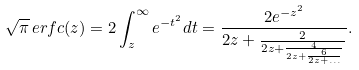Convert formula to latex. <formula><loc_0><loc_0><loc_500><loc_500>\sqrt { \pi } \, e r f c ( z ) = 2 \int ^ { \infty } _ { z } e ^ { - t ^ { 2 } } d t = \frac { 2 e ^ { - z ^ { 2 } } } { 2 z + \frac { 2 } { 2 z + \frac { 4 } { 2 z + \frac { 6 } { 2 z + \dots } } } } .</formula> 